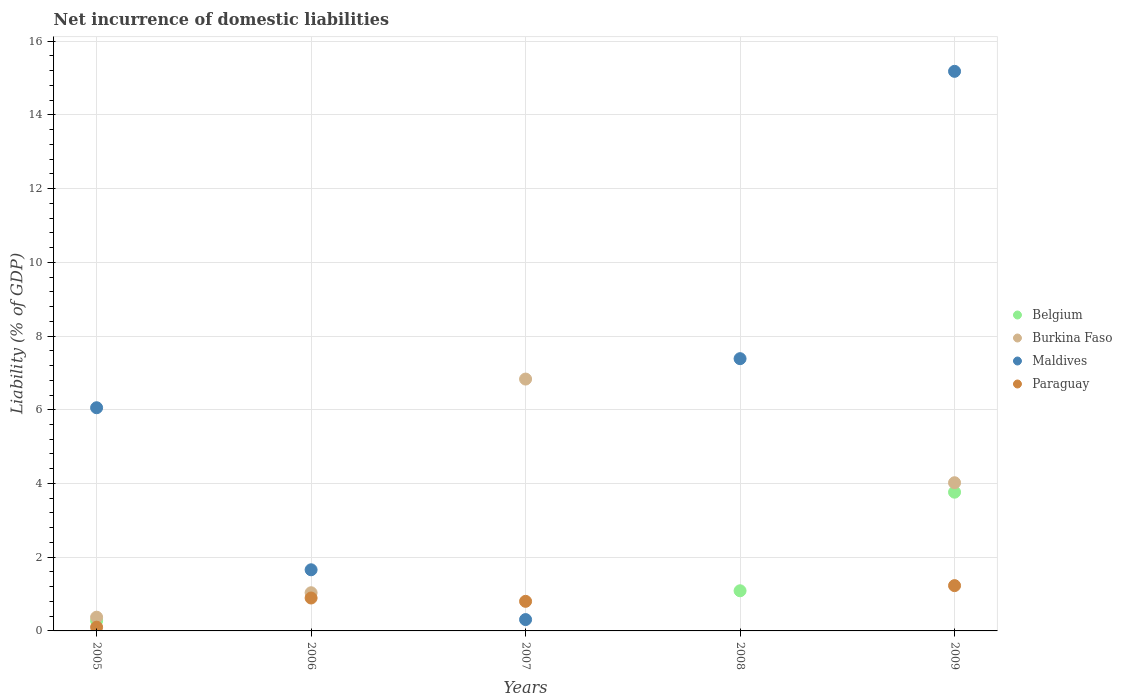How many different coloured dotlines are there?
Make the answer very short. 4. Is the number of dotlines equal to the number of legend labels?
Your answer should be compact. No. What is the net incurrence of domestic liabilities in Paraguay in 2006?
Give a very brief answer. 0.89. Across all years, what is the maximum net incurrence of domestic liabilities in Maldives?
Provide a short and direct response. 15.18. In which year was the net incurrence of domestic liabilities in Maldives maximum?
Your response must be concise. 2009. What is the total net incurrence of domestic liabilities in Paraguay in the graph?
Provide a succinct answer. 3.03. What is the difference between the net incurrence of domestic liabilities in Paraguay in 2005 and that in 2007?
Provide a short and direct response. -0.7. What is the difference between the net incurrence of domestic liabilities in Belgium in 2006 and the net incurrence of domestic liabilities in Burkina Faso in 2009?
Offer a terse response. -4.02. What is the average net incurrence of domestic liabilities in Paraguay per year?
Make the answer very short. 0.61. In the year 2006, what is the difference between the net incurrence of domestic liabilities in Paraguay and net incurrence of domestic liabilities in Burkina Faso?
Provide a short and direct response. -0.14. What is the ratio of the net incurrence of domestic liabilities in Maldives in 2005 to that in 2006?
Your answer should be compact. 3.65. What is the difference between the highest and the second highest net incurrence of domestic liabilities in Maldives?
Provide a short and direct response. 7.8. What is the difference between the highest and the lowest net incurrence of domestic liabilities in Maldives?
Your response must be concise. 14.87. In how many years, is the net incurrence of domestic liabilities in Paraguay greater than the average net incurrence of domestic liabilities in Paraguay taken over all years?
Offer a terse response. 3. Does the net incurrence of domestic liabilities in Belgium monotonically increase over the years?
Provide a short and direct response. No. Is the net incurrence of domestic liabilities in Maldives strictly less than the net incurrence of domestic liabilities in Belgium over the years?
Make the answer very short. No. How many dotlines are there?
Give a very brief answer. 4. What is the difference between two consecutive major ticks on the Y-axis?
Give a very brief answer. 2. Are the values on the major ticks of Y-axis written in scientific E-notation?
Your response must be concise. No. What is the title of the graph?
Keep it short and to the point. Net incurrence of domestic liabilities. Does "Isle of Man" appear as one of the legend labels in the graph?
Your answer should be compact. No. What is the label or title of the X-axis?
Your answer should be very brief. Years. What is the label or title of the Y-axis?
Provide a succinct answer. Liability (% of GDP). What is the Liability (% of GDP) in Belgium in 2005?
Give a very brief answer. 0.27. What is the Liability (% of GDP) of Burkina Faso in 2005?
Provide a succinct answer. 0.37. What is the Liability (% of GDP) in Maldives in 2005?
Give a very brief answer. 6.06. What is the Liability (% of GDP) in Paraguay in 2005?
Your answer should be compact. 0.1. What is the Liability (% of GDP) in Belgium in 2006?
Your answer should be compact. 0. What is the Liability (% of GDP) of Burkina Faso in 2006?
Your response must be concise. 1.04. What is the Liability (% of GDP) of Maldives in 2006?
Provide a succinct answer. 1.66. What is the Liability (% of GDP) in Paraguay in 2006?
Offer a very short reply. 0.89. What is the Liability (% of GDP) of Belgium in 2007?
Make the answer very short. 0. What is the Liability (% of GDP) in Burkina Faso in 2007?
Give a very brief answer. 6.83. What is the Liability (% of GDP) in Maldives in 2007?
Give a very brief answer. 0.31. What is the Liability (% of GDP) in Paraguay in 2007?
Give a very brief answer. 0.8. What is the Liability (% of GDP) of Belgium in 2008?
Provide a succinct answer. 1.09. What is the Liability (% of GDP) of Maldives in 2008?
Your response must be concise. 7.39. What is the Liability (% of GDP) of Paraguay in 2008?
Your response must be concise. 0. What is the Liability (% of GDP) of Belgium in 2009?
Provide a short and direct response. 3.76. What is the Liability (% of GDP) in Burkina Faso in 2009?
Ensure brevity in your answer.  4.02. What is the Liability (% of GDP) in Maldives in 2009?
Provide a short and direct response. 15.18. What is the Liability (% of GDP) in Paraguay in 2009?
Give a very brief answer. 1.23. Across all years, what is the maximum Liability (% of GDP) in Belgium?
Give a very brief answer. 3.76. Across all years, what is the maximum Liability (% of GDP) of Burkina Faso?
Provide a succinct answer. 6.83. Across all years, what is the maximum Liability (% of GDP) of Maldives?
Your answer should be compact. 15.18. Across all years, what is the maximum Liability (% of GDP) of Paraguay?
Give a very brief answer. 1.23. Across all years, what is the minimum Liability (% of GDP) in Maldives?
Your answer should be compact. 0.31. What is the total Liability (% of GDP) of Belgium in the graph?
Provide a short and direct response. 5.13. What is the total Liability (% of GDP) in Burkina Faso in the graph?
Offer a very short reply. 12.26. What is the total Liability (% of GDP) of Maldives in the graph?
Give a very brief answer. 30.59. What is the total Liability (% of GDP) in Paraguay in the graph?
Your answer should be compact. 3.03. What is the difference between the Liability (% of GDP) in Burkina Faso in 2005 and that in 2006?
Ensure brevity in your answer.  -0.66. What is the difference between the Liability (% of GDP) of Maldives in 2005 and that in 2006?
Ensure brevity in your answer.  4.4. What is the difference between the Liability (% of GDP) of Paraguay in 2005 and that in 2006?
Provide a short and direct response. -0.79. What is the difference between the Liability (% of GDP) in Burkina Faso in 2005 and that in 2007?
Offer a very short reply. -6.46. What is the difference between the Liability (% of GDP) in Maldives in 2005 and that in 2007?
Provide a succinct answer. 5.75. What is the difference between the Liability (% of GDP) of Paraguay in 2005 and that in 2007?
Ensure brevity in your answer.  -0.7. What is the difference between the Liability (% of GDP) in Belgium in 2005 and that in 2008?
Provide a succinct answer. -0.81. What is the difference between the Liability (% of GDP) in Maldives in 2005 and that in 2008?
Ensure brevity in your answer.  -1.33. What is the difference between the Liability (% of GDP) of Belgium in 2005 and that in 2009?
Your answer should be compact. -3.49. What is the difference between the Liability (% of GDP) in Burkina Faso in 2005 and that in 2009?
Provide a succinct answer. -3.65. What is the difference between the Liability (% of GDP) in Maldives in 2005 and that in 2009?
Offer a very short reply. -9.13. What is the difference between the Liability (% of GDP) in Paraguay in 2005 and that in 2009?
Your answer should be compact. -1.13. What is the difference between the Liability (% of GDP) of Burkina Faso in 2006 and that in 2007?
Provide a short and direct response. -5.8. What is the difference between the Liability (% of GDP) in Maldives in 2006 and that in 2007?
Give a very brief answer. 1.35. What is the difference between the Liability (% of GDP) of Paraguay in 2006 and that in 2007?
Your answer should be very brief. 0.09. What is the difference between the Liability (% of GDP) in Maldives in 2006 and that in 2008?
Offer a terse response. -5.73. What is the difference between the Liability (% of GDP) of Burkina Faso in 2006 and that in 2009?
Offer a very short reply. -2.98. What is the difference between the Liability (% of GDP) of Maldives in 2006 and that in 2009?
Make the answer very short. -13.52. What is the difference between the Liability (% of GDP) in Paraguay in 2006 and that in 2009?
Offer a very short reply. -0.34. What is the difference between the Liability (% of GDP) of Maldives in 2007 and that in 2008?
Provide a succinct answer. -7.08. What is the difference between the Liability (% of GDP) in Burkina Faso in 2007 and that in 2009?
Your answer should be compact. 2.81. What is the difference between the Liability (% of GDP) in Maldives in 2007 and that in 2009?
Offer a very short reply. -14.87. What is the difference between the Liability (% of GDP) in Paraguay in 2007 and that in 2009?
Make the answer very short. -0.43. What is the difference between the Liability (% of GDP) of Belgium in 2008 and that in 2009?
Make the answer very short. -2.67. What is the difference between the Liability (% of GDP) of Maldives in 2008 and that in 2009?
Offer a terse response. -7.8. What is the difference between the Liability (% of GDP) in Belgium in 2005 and the Liability (% of GDP) in Burkina Faso in 2006?
Ensure brevity in your answer.  -0.76. What is the difference between the Liability (% of GDP) in Belgium in 2005 and the Liability (% of GDP) in Maldives in 2006?
Your answer should be compact. -1.38. What is the difference between the Liability (% of GDP) of Belgium in 2005 and the Liability (% of GDP) of Paraguay in 2006?
Offer a very short reply. -0.62. What is the difference between the Liability (% of GDP) in Burkina Faso in 2005 and the Liability (% of GDP) in Maldives in 2006?
Provide a short and direct response. -1.29. What is the difference between the Liability (% of GDP) of Burkina Faso in 2005 and the Liability (% of GDP) of Paraguay in 2006?
Make the answer very short. -0.52. What is the difference between the Liability (% of GDP) in Maldives in 2005 and the Liability (% of GDP) in Paraguay in 2006?
Ensure brevity in your answer.  5.16. What is the difference between the Liability (% of GDP) in Belgium in 2005 and the Liability (% of GDP) in Burkina Faso in 2007?
Your response must be concise. -6.56. What is the difference between the Liability (% of GDP) in Belgium in 2005 and the Liability (% of GDP) in Maldives in 2007?
Your answer should be compact. -0.03. What is the difference between the Liability (% of GDP) in Belgium in 2005 and the Liability (% of GDP) in Paraguay in 2007?
Keep it short and to the point. -0.53. What is the difference between the Liability (% of GDP) in Burkina Faso in 2005 and the Liability (% of GDP) in Maldives in 2007?
Your answer should be compact. 0.06. What is the difference between the Liability (% of GDP) in Burkina Faso in 2005 and the Liability (% of GDP) in Paraguay in 2007?
Give a very brief answer. -0.43. What is the difference between the Liability (% of GDP) of Maldives in 2005 and the Liability (% of GDP) of Paraguay in 2007?
Provide a short and direct response. 5.25. What is the difference between the Liability (% of GDP) of Belgium in 2005 and the Liability (% of GDP) of Maldives in 2008?
Your response must be concise. -7.11. What is the difference between the Liability (% of GDP) in Burkina Faso in 2005 and the Liability (% of GDP) in Maldives in 2008?
Ensure brevity in your answer.  -7.01. What is the difference between the Liability (% of GDP) in Belgium in 2005 and the Liability (% of GDP) in Burkina Faso in 2009?
Ensure brevity in your answer.  -3.75. What is the difference between the Liability (% of GDP) of Belgium in 2005 and the Liability (% of GDP) of Maldives in 2009?
Provide a short and direct response. -14.91. What is the difference between the Liability (% of GDP) in Belgium in 2005 and the Liability (% of GDP) in Paraguay in 2009?
Offer a terse response. -0.95. What is the difference between the Liability (% of GDP) in Burkina Faso in 2005 and the Liability (% of GDP) in Maldives in 2009?
Offer a very short reply. -14.81. What is the difference between the Liability (% of GDP) of Burkina Faso in 2005 and the Liability (% of GDP) of Paraguay in 2009?
Offer a very short reply. -0.86. What is the difference between the Liability (% of GDP) of Maldives in 2005 and the Liability (% of GDP) of Paraguay in 2009?
Keep it short and to the point. 4.83. What is the difference between the Liability (% of GDP) of Burkina Faso in 2006 and the Liability (% of GDP) of Maldives in 2007?
Your answer should be compact. 0.73. What is the difference between the Liability (% of GDP) of Burkina Faso in 2006 and the Liability (% of GDP) of Paraguay in 2007?
Provide a short and direct response. 0.23. What is the difference between the Liability (% of GDP) in Maldives in 2006 and the Liability (% of GDP) in Paraguay in 2007?
Offer a very short reply. 0.86. What is the difference between the Liability (% of GDP) in Burkina Faso in 2006 and the Liability (% of GDP) in Maldives in 2008?
Give a very brief answer. -6.35. What is the difference between the Liability (% of GDP) in Burkina Faso in 2006 and the Liability (% of GDP) in Maldives in 2009?
Give a very brief answer. -14.15. What is the difference between the Liability (% of GDP) of Burkina Faso in 2006 and the Liability (% of GDP) of Paraguay in 2009?
Keep it short and to the point. -0.19. What is the difference between the Liability (% of GDP) in Maldives in 2006 and the Liability (% of GDP) in Paraguay in 2009?
Ensure brevity in your answer.  0.43. What is the difference between the Liability (% of GDP) of Burkina Faso in 2007 and the Liability (% of GDP) of Maldives in 2008?
Provide a short and direct response. -0.55. What is the difference between the Liability (% of GDP) of Burkina Faso in 2007 and the Liability (% of GDP) of Maldives in 2009?
Keep it short and to the point. -8.35. What is the difference between the Liability (% of GDP) in Burkina Faso in 2007 and the Liability (% of GDP) in Paraguay in 2009?
Your answer should be very brief. 5.6. What is the difference between the Liability (% of GDP) in Maldives in 2007 and the Liability (% of GDP) in Paraguay in 2009?
Your response must be concise. -0.92. What is the difference between the Liability (% of GDP) in Belgium in 2008 and the Liability (% of GDP) in Burkina Faso in 2009?
Keep it short and to the point. -2.93. What is the difference between the Liability (% of GDP) in Belgium in 2008 and the Liability (% of GDP) in Maldives in 2009?
Offer a terse response. -14.09. What is the difference between the Liability (% of GDP) of Belgium in 2008 and the Liability (% of GDP) of Paraguay in 2009?
Ensure brevity in your answer.  -0.14. What is the difference between the Liability (% of GDP) of Maldives in 2008 and the Liability (% of GDP) of Paraguay in 2009?
Your answer should be very brief. 6.16. What is the average Liability (% of GDP) in Belgium per year?
Keep it short and to the point. 1.03. What is the average Liability (% of GDP) of Burkina Faso per year?
Offer a terse response. 2.45. What is the average Liability (% of GDP) of Maldives per year?
Provide a short and direct response. 6.12. What is the average Liability (% of GDP) in Paraguay per year?
Keep it short and to the point. 0.61. In the year 2005, what is the difference between the Liability (% of GDP) of Belgium and Liability (% of GDP) of Burkina Faso?
Provide a succinct answer. -0.1. In the year 2005, what is the difference between the Liability (% of GDP) of Belgium and Liability (% of GDP) of Maldives?
Ensure brevity in your answer.  -5.78. In the year 2005, what is the difference between the Liability (% of GDP) in Belgium and Liability (% of GDP) in Paraguay?
Your answer should be very brief. 0.17. In the year 2005, what is the difference between the Liability (% of GDP) in Burkina Faso and Liability (% of GDP) in Maldives?
Offer a terse response. -5.68. In the year 2005, what is the difference between the Liability (% of GDP) of Burkina Faso and Liability (% of GDP) of Paraguay?
Your answer should be compact. 0.27. In the year 2005, what is the difference between the Liability (% of GDP) of Maldives and Liability (% of GDP) of Paraguay?
Make the answer very short. 5.95. In the year 2006, what is the difference between the Liability (% of GDP) of Burkina Faso and Liability (% of GDP) of Maldives?
Your response must be concise. -0.62. In the year 2006, what is the difference between the Liability (% of GDP) of Burkina Faso and Liability (% of GDP) of Paraguay?
Provide a succinct answer. 0.14. In the year 2006, what is the difference between the Liability (% of GDP) in Maldives and Liability (% of GDP) in Paraguay?
Your answer should be compact. 0.77. In the year 2007, what is the difference between the Liability (% of GDP) in Burkina Faso and Liability (% of GDP) in Maldives?
Your answer should be very brief. 6.53. In the year 2007, what is the difference between the Liability (% of GDP) in Burkina Faso and Liability (% of GDP) in Paraguay?
Make the answer very short. 6.03. In the year 2007, what is the difference between the Liability (% of GDP) in Maldives and Liability (% of GDP) in Paraguay?
Ensure brevity in your answer.  -0.49. In the year 2008, what is the difference between the Liability (% of GDP) in Belgium and Liability (% of GDP) in Maldives?
Your response must be concise. -6.3. In the year 2009, what is the difference between the Liability (% of GDP) of Belgium and Liability (% of GDP) of Burkina Faso?
Keep it short and to the point. -0.26. In the year 2009, what is the difference between the Liability (% of GDP) in Belgium and Liability (% of GDP) in Maldives?
Your answer should be very brief. -11.42. In the year 2009, what is the difference between the Liability (% of GDP) of Belgium and Liability (% of GDP) of Paraguay?
Your response must be concise. 2.54. In the year 2009, what is the difference between the Liability (% of GDP) in Burkina Faso and Liability (% of GDP) in Maldives?
Your response must be concise. -11.16. In the year 2009, what is the difference between the Liability (% of GDP) of Burkina Faso and Liability (% of GDP) of Paraguay?
Your answer should be very brief. 2.79. In the year 2009, what is the difference between the Liability (% of GDP) of Maldives and Liability (% of GDP) of Paraguay?
Offer a terse response. 13.95. What is the ratio of the Liability (% of GDP) in Burkina Faso in 2005 to that in 2006?
Ensure brevity in your answer.  0.36. What is the ratio of the Liability (% of GDP) of Maldives in 2005 to that in 2006?
Provide a short and direct response. 3.65. What is the ratio of the Liability (% of GDP) of Paraguay in 2005 to that in 2006?
Make the answer very short. 0.11. What is the ratio of the Liability (% of GDP) in Burkina Faso in 2005 to that in 2007?
Your response must be concise. 0.05. What is the ratio of the Liability (% of GDP) in Maldives in 2005 to that in 2007?
Give a very brief answer. 19.67. What is the ratio of the Liability (% of GDP) in Paraguay in 2005 to that in 2007?
Offer a very short reply. 0.13. What is the ratio of the Liability (% of GDP) of Belgium in 2005 to that in 2008?
Make the answer very short. 0.25. What is the ratio of the Liability (% of GDP) of Maldives in 2005 to that in 2008?
Provide a short and direct response. 0.82. What is the ratio of the Liability (% of GDP) in Belgium in 2005 to that in 2009?
Provide a succinct answer. 0.07. What is the ratio of the Liability (% of GDP) of Burkina Faso in 2005 to that in 2009?
Offer a very short reply. 0.09. What is the ratio of the Liability (% of GDP) of Maldives in 2005 to that in 2009?
Offer a terse response. 0.4. What is the ratio of the Liability (% of GDP) in Paraguay in 2005 to that in 2009?
Make the answer very short. 0.08. What is the ratio of the Liability (% of GDP) of Burkina Faso in 2006 to that in 2007?
Your answer should be compact. 0.15. What is the ratio of the Liability (% of GDP) of Maldives in 2006 to that in 2007?
Keep it short and to the point. 5.39. What is the ratio of the Liability (% of GDP) in Paraguay in 2006 to that in 2007?
Keep it short and to the point. 1.11. What is the ratio of the Liability (% of GDP) in Maldives in 2006 to that in 2008?
Ensure brevity in your answer.  0.22. What is the ratio of the Liability (% of GDP) in Burkina Faso in 2006 to that in 2009?
Provide a succinct answer. 0.26. What is the ratio of the Liability (% of GDP) in Maldives in 2006 to that in 2009?
Give a very brief answer. 0.11. What is the ratio of the Liability (% of GDP) in Paraguay in 2006 to that in 2009?
Provide a succinct answer. 0.73. What is the ratio of the Liability (% of GDP) in Maldives in 2007 to that in 2008?
Offer a terse response. 0.04. What is the ratio of the Liability (% of GDP) of Burkina Faso in 2007 to that in 2009?
Ensure brevity in your answer.  1.7. What is the ratio of the Liability (% of GDP) in Maldives in 2007 to that in 2009?
Keep it short and to the point. 0.02. What is the ratio of the Liability (% of GDP) in Paraguay in 2007 to that in 2009?
Your answer should be very brief. 0.65. What is the ratio of the Liability (% of GDP) in Belgium in 2008 to that in 2009?
Ensure brevity in your answer.  0.29. What is the ratio of the Liability (% of GDP) of Maldives in 2008 to that in 2009?
Offer a terse response. 0.49. What is the difference between the highest and the second highest Liability (% of GDP) of Belgium?
Provide a short and direct response. 2.67. What is the difference between the highest and the second highest Liability (% of GDP) in Burkina Faso?
Make the answer very short. 2.81. What is the difference between the highest and the second highest Liability (% of GDP) in Maldives?
Your answer should be compact. 7.8. What is the difference between the highest and the second highest Liability (% of GDP) of Paraguay?
Your response must be concise. 0.34. What is the difference between the highest and the lowest Liability (% of GDP) in Belgium?
Provide a short and direct response. 3.76. What is the difference between the highest and the lowest Liability (% of GDP) in Burkina Faso?
Your answer should be very brief. 6.83. What is the difference between the highest and the lowest Liability (% of GDP) of Maldives?
Your answer should be compact. 14.87. What is the difference between the highest and the lowest Liability (% of GDP) of Paraguay?
Your answer should be very brief. 1.23. 